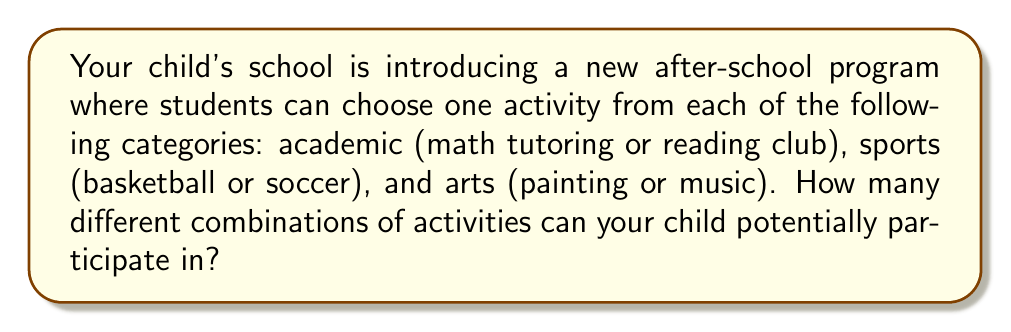Show me your answer to this math problem. To solve this problem, we'll use the multiplication principle of counting. This principle states that if we have a sequence of independent choices, the total number of possible outcomes is the product of the number of options for each choice.

Let's break down the choices:

1. Academic category: 2 options (math tutoring or reading club)
2. Sports category: 2 options (basketball or soccer)
3. Arts category: 2 options (painting or music)

For each category, your child must choose exactly one option. The choices in each category are independent of the choices in other categories.

To calculate the total number of possible combinations:

$$ \text{Total combinations} = \text{Academic options} \times \text{Sports options} \times \text{Arts options} $$

$$ \text{Total combinations} = 2 \times 2 \times 2 = 8 $$

We can also represent this visually using a tree diagram:

[asy]
unitsize(1cm);

draw((0,0)--(2,1), arrow=Arrow());
draw((0,0)--(2,-1), arrow=Arrow());
draw((2,1)--(4,1.5), arrow=Arrow());
draw((2,1)--(4,0.5), arrow=Arrow());
draw((2,-1)--(4,-0.5), arrow=Arrow());
draw((2,-1)--(4,-1.5), arrow=Arrow());
draw((4,1.5)--(6,2), arrow=Arrow());
draw((4,1.5)--(6,1), arrow=Arrow());
draw((4,0.5)--(6,0.5), arrow=Arrow());
draw((4,0.5)--(6,-0.5), arrow=Arrow());
draw((4,-0.5)--(6,-1), arrow=Arrow());
draw((4,-0.5)--(6,-2), arrow=Arrow());
draw((4,-1.5)--(6,-2.5), arrow=Arrow());
draw((4,-1.5)--(6,-3.5), arrow=Arrow());

label("Math", (1,1), N);
label("Reading", (1,-1), S);
label("Basketball", (3,1.5), N);
label("Soccer", (3,0.5), N);
label("Basketball", (3,-0.5), S);
label("Soccer", (3,-1.5), S);
label("Painting", (5,2), NE);
label("Music", (5,1), NE);
label("Painting", (5,0.5), NE);
label("Music", (5,-0.5), NE);
label("Painting", (5,-1), SE);
label("Music", (5,-2), SE);
label("Painting", (5,-2.5), SE);
label("Music", (5,-3.5), SE);
[/asy]

Each path from left to right represents a unique combination of choices, and there are 8 such paths, confirming our calculation.
Answer: There are 8 different combinations of activities that your child can potentially participate in for the new after-school program. 